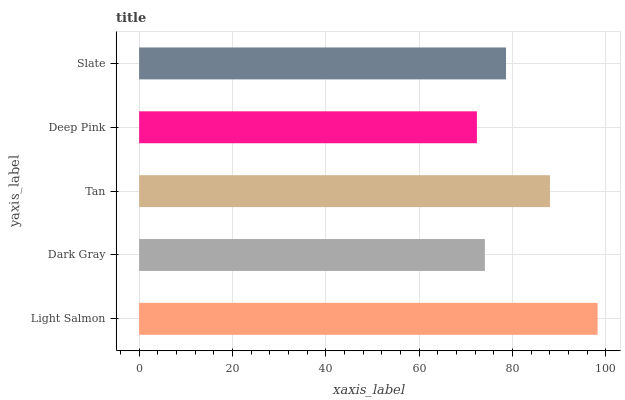Is Deep Pink the minimum?
Answer yes or no. Yes. Is Light Salmon the maximum?
Answer yes or no. Yes. Is Dark Gray the minimum?
Answer yes or no. No. Is Dark Gray the maximum?
Answer yes or no. No. Is Light Salmon greater than Dark Gray?
Answer yes or no. Yes. Is Dark Gray less than Light Salmon?
Answer yes or no. Yes. Is Dark Gray greater than Light Salmon?
Answer yes or no. No. Is Light Salmon less than Dark Gray?
Answer yes or no. No. Is Slate the high median?
Answer yes or no. Yes. Is Slate the low median?
Answer yes or no. Yes. Is Deep Pink the high median?
Answer yes or no. No. Is Dark Gray the low median?
Answer yes or no. No. 